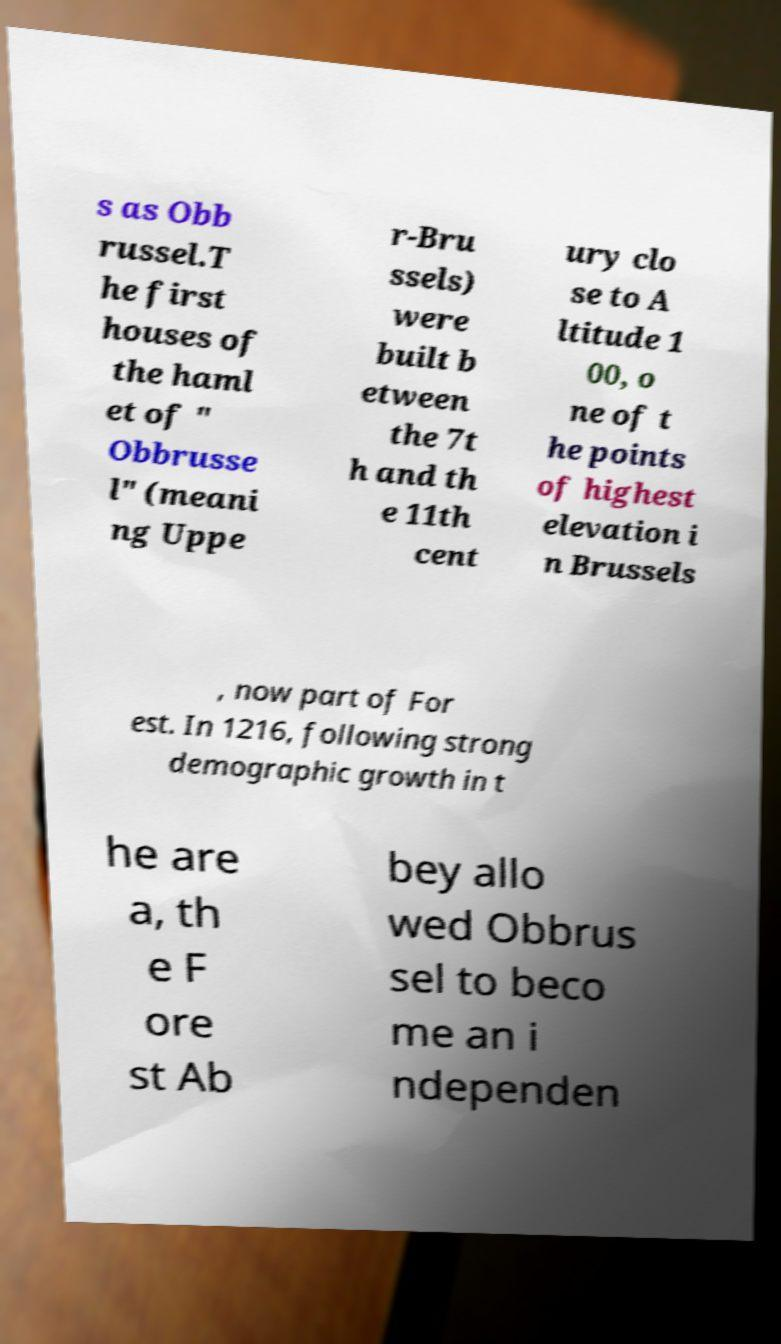Could you assist in decoding the text presented in this image and type it out clearly? s as Obb russel.T he first houses of the haml et of " Obbrusse l" (meani ng Uppe r-Bru ssels) were built b etween the 7t h and th e 11th cent ury clo se to A ltitude 1 00, o ne of t he points of highest elevation i n Brussels , now part of For est. In 1216, following strong demographic growth in t he are a, th e F ore st Ab bey allo wed Obbrus sel to beco me an i ndependen 